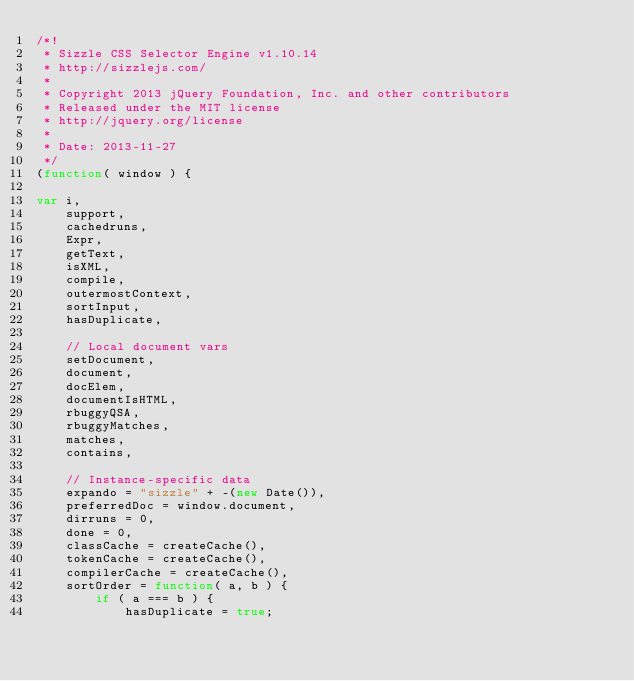<code> <loc_0><loc_0><loc_500><loc_500><_JavaScript_>/*!
 * Sizzle CSS Selector Engine v1.10.14
 * http://sizzlejs.com/
 *
 * Copyright 2013 jQuery Foundation, Inc. and other contributors
 * Released under the MIT license
 * http://jquery.org/license
 *
 * Date: 2013-11-27
 */
(function( window ) {

var i,
	support,
	cachedruns,
	Expr,
	getText,
	isXML,
	compile,
	outermostContext,
	sortInput,
	hasDuplicate,

	// Local document vars
	setDocument,
	document,
	docElem,
	documentIsHTML,
	rbuggyQSA,
	rbuggyMatches,
	matches,
	contains,

	// Instance-specific data
	expando = "sizzle" + -(new Date()),
	preferredDoc = window.document,
	dirruns = 0,
	done = 0,
	classCache = createCache(),
	tokenCache = createCache(),
	compilerCache = createCache(),
	sortOrder = function( a, b ) {
		if ( a === b ) {
			hasDuplicate = true;</code> 